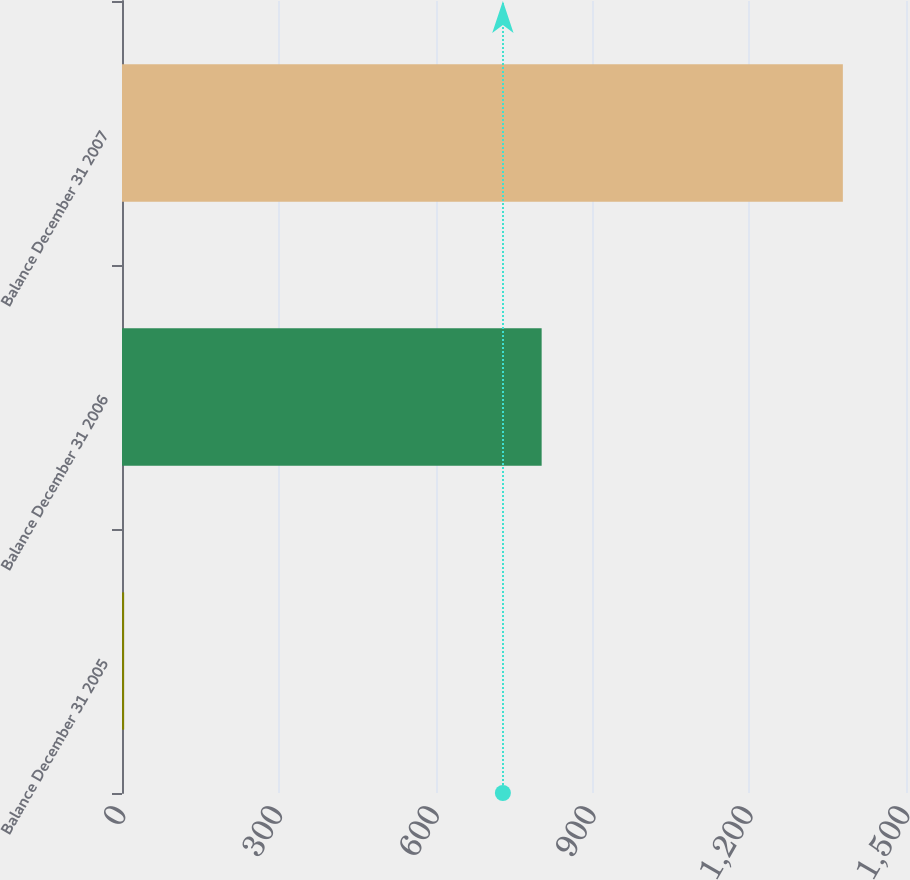Convert chart to OTSL. <chart><loc_0><loc_0><loc_500><loc_500><bar_chart><fcel>Balance December 31 2005<fcel>Balance December 31 2006<fcel>Balance December 31 2007<nl><fcel>4.1<fcel>802.9<fcel>1379.2<nl></chart> 